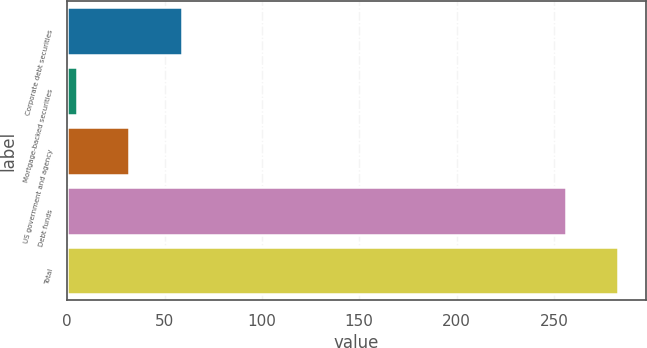Convert chart. <chart><loc_0><loc_0><loc_500><loc_500><bar_chart><fcel>Corporate debt securities<fcel>Mortgage-backed securities<fcel>US government and agency<fcel>Debt funds<fcel>Total<nl><fcel>59<fcel>5<fcel>32<fcel>256<fcel>283<nl></chart> 